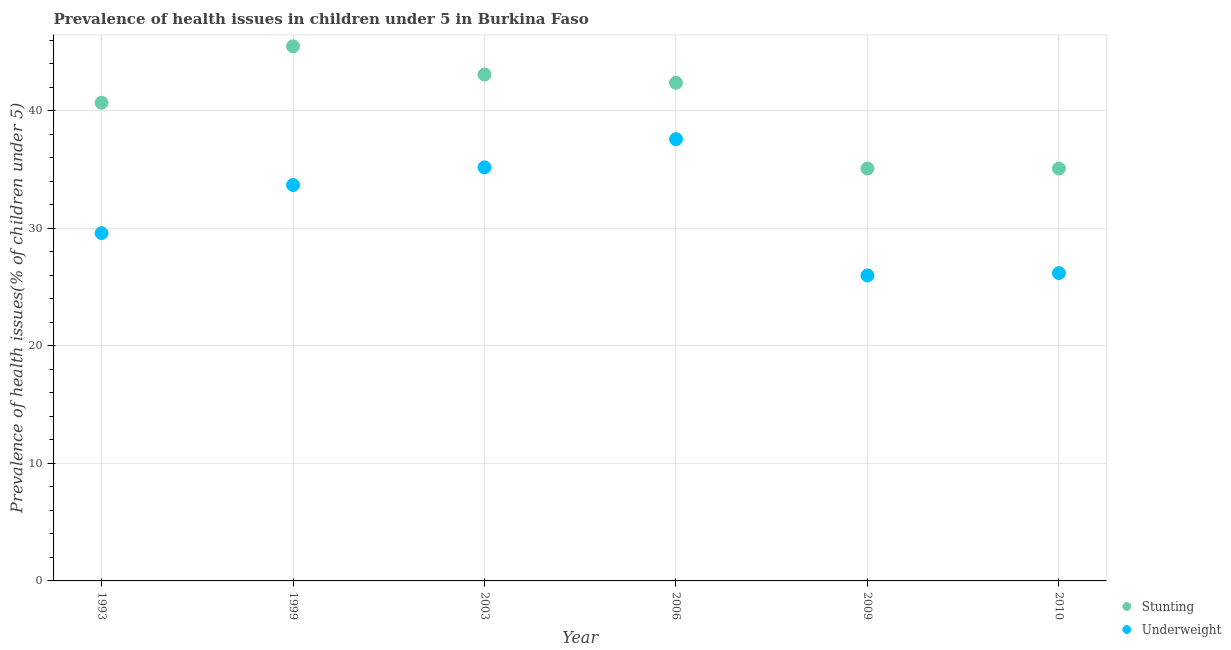What is the percentage of stunted children in 1999?
Your response must be concise. 45.5. Across all years, what is the maximum percentage of underweight children?
Your answer should be very brief. 37.6. Across all years, what is the minimum percentage of underweight children?
Give a very brief answer. 26. What is the total percentage of underweight children in the graph?
Provide a succinct answer. 188.3. What is the difference between the percentage of stunted children in 1993 and that in 2009?
Your answer should be compact. 5.6. What is the difference between the percentage of stunted children in 2003 and the percentage of underweight children in 2009?
Your answer should be very brief. 17.1. What is the average percentage of underweight children per year?
Offer a terse response. 31.38. In the year 2009, what is the difference between the percentage of underweight children and percentage of stunted children?
Ensure brevity in your answer.  -9.1. What is the ratio of the percentage of stunted children in 2003 to that in 2006?
Keep it short and to the point. 1.02. Is the difference between the percentage of underweight children in 1993 and 2010 greater than the difference between the percentage of stunted children in 1993 and 2010?
Ensure brevity in your answer.  No. What is the difference between the highest and the second highest percentage of underweight children?
Your answer should be very brief. 2.4. What is the difference between the highest and the lowest percentage of stunted children?
Offer a terse response. 10.4. In how many years, is the percentage of underweight children greater than the average percentage of underweight children taken over all years?
Keep it short and to the point. 3. Does the percentage of underweight children monotonically increase over the years?
Your answer should be very brief. No. Is the percentage of underweight children strictly greater than the percentage of stunted children over the years?
Provide a short and direct response. No. Is the percentage of underweight children strictly less than the percentage of stunted children over the years?
Provide a succinct answer. Yes. How many dotlines are there?
Provide a short and direct response. 2. How many years are there in the graph?
Provide a succinct answer. 6. Are the values on the major ticks of Y-axis written in scientific E-notation?
Make the answer very short. No. Does the graph contain any zero values?
Offer a terse response. No. Does the graph contain grids?
Offer a terse response. Yes. How many legend labels are there?
Provide a succinct answer. 2. How are the legend labels stacked?
Give a very brief answer. Vertical. What is the title of the graph?
Your response must be concise. Prevalence of health issues in children under 5 in Burkina Faso. What is the label or title of the Y-axis?
Ensure brevity in your answer.  Prevalence of health issues(% of children under 5). What is the Prevalence of health issues(% of children under 5) of Stunting in 1993?
Keep it short and to the point. 40.7. What is the Prevalence of health issues(% of children under 5) of Underweight in 1993?
Your response must be concise. 29.6. What is the Prevalence of health issues(% of children under 5) of Stunting in 1999?
Your answer should be compact. 45.5. What is the Prevalence of health issues(% of children under 5) in Underweight in 1999?
Provide a short and direct response. 33.7. What is the Prevalence of health issues(% of children under 5) of Stunting in 2003?
Keep it short and to the point. 43.1. What is the Prevalence of health issues(% of children under 5) of Underweight in 2003?
Your response must be concise. 35.2. What is the Prevalence of health issues(% of children under 5) in Stunting in 2006?
Your answer should be very brief. 42.4. What is the Prevalence of health issues(% of children under 5) in Underweight in 2006?
Your response must be concise. 37.6. What is the Prevalence of health issues(% of children under 5) in Stunting in 2009?
Your response must be concise. 35.1. What is the Prevalence of health issues(% of children under 5) of Stunting in 2010?
Your response must be concise. 35.1. What is the Prevalence of health issues(% of children under 5) in Underweight in 2010?
Make the answer very short. 26.2. Across all years, what is the maximum Prevalence of health issues(% of children under 5) in Stunting?
Your answer should be compact. 45.5. Across all years, what is the maximum Prevalence of health issues(% of children under 5) in Underweight?
Keep it short and to the point. 37.6. Across all years, what is the minimum Prevalence of health issues(% of children under 5) in Stunting?
Your answer should be very brief. 35.1. What is the total Prevalence of health issues(% of children under 5) in Stunting in the graph?
Your answer should be very brief. 241.9. What is the total Prevalence of health issues(% of children under 5) of Underweight in the graph?
Your response must be concise. 188.3. What is the difference between the Prevalence of health issues(% of children under 5) of Underweight in 1993 and that in 1999?
Make the answer very short. -4.1. What is the difference between the Prevalence of health issues(% of children under 5) in Underweight in 1993 and that in 2003?
Your response must be concise. -5.6. What is the difference between the Prevalence of health issues(% of children under 5) in Stunting in 1993 and that in 2006?
Offer a terse response. -1.7. What is the difference between the Prevalence of health issues(% of children under 5) of Stunting in 1993 and that in 2009?
Make the answer very short. 5.6. What is the difference between the Prevalence of health issues(% of children under 5) in Underweight in 1993 and that in 2009?
Keep it short and to the point. 3.6. What is the difference between the Prevalence of health issues(% of children under 5) in Underweight in 1993 and that in 2010?
Make the answer very short. 3.4. What is the difference between the Prevalence of health issues(% of children under 5) of Underweight in 1999 and that in 2003?
Your answer should be very brief. -1.5. What is the difference between the Prevalence of health issues(% of children under 5) in Underweight in 1999 and that in 2006?
Make the answer very short. -3.9. What is the difference between the Prevalence of health issues(% of children under 5) in Stunting in 1999 and that in 2009?
Your response must be concise. 10.4. What is the difference between the Prevalence of health issues(% of children under 5) in Stunting in 1999 and that in 2010?
Provide a succinct answer. 10.4. What is the difference between the Prevalence of health issues(% of children under 5) in Underweight in 2003 and that in 2006?
Your response must be concise. -2.4. What is the difference between the Prevalence of health issues(% of children under 5) in Stunting in 2003 and that in 2009?
Your answer should be compact. 8. What is the difference between the Prevalence of health issues(% of children under 5) in Underweight in 2003 and that in 2010?
Keep it short and to the point. 9. What is the difference between the Prevalence of health issues(% of children under 5) of Stunting in 2006 and that in 2009?
Provide a succinct answer. 7.3. What is the difference between the Prevalence of health issues(% of children under 5) of Stunting in 2006 and that in 2010?
Your answer should be very brief. 7.3. What is the difference between the Prevalence of health issues(% of children under 5) in Underweight in 2006 and that in 2010?
Make the answer very short. 11.4. What is the difference between the Prevalence of health issues(% of children under 5) in Stunting in 2009 and that in 2010?
Provide a succinct answer. 0. What is the difference between the Prevalence of health issues(% of children under 5) in Stunting in 1993 and the Prevalence of health issues(% of children under 5) in Underweight in 1999?
Provide a succinct answer. 7. What is the difference between the Prevalence of health issues(% of children under 5) in Stunting in 1993 and the Prevalence of health issues(% of children under 5) in Underweight in 2006?
Give a very brief answer. 3.1. What is the difference between the Prevalence of health issues(% of children under 5) in Stunting in 1993 and the Prevalence of health issues(% of children under 5) in Underweight in 2009?
Make the answer very short. 14.7. What is the difference between the Prevalence of health issues(% of children under 5) in Stunting in 1993 and the Prevalence of health issues(% of children under 5) in Underweight in 2010?
Provide a succinct answer. 14.5. What is the difference between the Prevalence of health issues(% of children under 5) in Stunting in 1999 and the Prevalence of health issues(% of children under 5) in Underweight in 2003?
Your response must be concise. 10.3. What is the difference between the Prevalence of health issues(% of children under 5) of Stunting in 1999 and the Prevalence of health issues(% of children under 5) of Underweight in 2010?
Provide a short and direct response. 19.3. What is the difference between the Prevalence of health issues(% of children under 5) in Stunting in 2003 and the Prevalence of health issues(% of children under 5) in Underweight in 2010?
Offer a terse response. 16.9. What is the difference between the Prevalence of health issues(% of children under 5) of Stunting in 2006 and the Prevalence of health issues(% of children under 5) of Underweight in 2009?
Give a very brief answer. 16.4. What is the difference between the Prevalence of health issues(% of children under 5) of Stunting in 2006 and the Prevalence of health issues(% of children under 5) of Underweight in 2010?
Provide a short and direct response. 16.2. What is the difference between the Prevalence of health issues(% of children under 5) of Stunting in 2009 and the Prevalence of health issues(% of children under 5) of Underweight in 2010?
Offer a terse response. 8.9. What is the average Prevalence of health issues(% of children under 5) of Stunting per year?
Give a very brief answer. 40.32. What is the average Prevalence of health issues(% of children under 5) in Underweight per year?
Keep it short and to the point. 31.38. In the year 1999, what is the difference between the Prevalence of health issues(% of children under 5) in Stunting and Prevalence of health issues(% of children under 5) in Underweight?
Your answer should be compact. 11.8. In the year 2009, what is the difference between the Prevalence of health issues(% of children under 5) in Stunting and Prevalence of health issues(% of children under 5) in Underweight?
Provide a short and direct response. 9.1. In the year 2010, what is the difference between the Prevalence of health issues(% of children under 5) of Stunting and Prevalence of health issues(% of children under 5) of Underweight?
Offer a terse response. 8.9. What is the ratio of the Prevalence of health issues(% of children under 5) in Stunting in 1993 to that in 1999?
Your answer should be compact. 0.89. What is the ratio of the Prevalence of health issues(% of children under 5) in Underweight in 1993 to that in 1999?
Provide a short and direct response. 0.88. What is the ratio of the Prevalence of health issues(% of children under 5) of Stunting in 1993 to that in 2003?
Your answer should be very brief. 0.94. What is the ratio of the Prevalence of health issues(% of children under 5) in Underweight in 1993 to that in 2003?
Give a very brief answer. 0.84. What is the ratio of the Prevalence of health issues(% of children under 5) in Stunting in 1993 to that in 2006?
Your response must be concise. 0.96. What is the ratio of the Prevalence of health issues(% of children under 5) in Underweight in 1993 to that in 2006?
Offer a very short reply. 0.79. What is the ratio of the Prevalence of health issues(% of children under 5) of Stunting in 1993 to that in 2009?
Provide a short and direct response. 1.16. What is the ratio of the Prevalence of health issues(% of children under 5) of Underweight in 1993 to that in 2009?
Make the answer very short. 1.14. What is the ratio of the Prevalence of health issues(% of children under 5) in Stunting in 1993 to that in 2010?
Keep it short and to the point. 1.16. What is the ratio of the Prevalence of health issues(% of children under 5) in Underweight in 1993 to that in 2010?
Provide a short and direct response. 1.13. What is the ratio of the Prevalence of health issues(% of children under 5) in Stunting in 1999 to that in 2003?
Offer a terse response. 1.06. What is the ratio of the Prevalence of health issues(% of children under 5) in Underweight in 1999 to that in 2003?
Ensure brevity in your answer.  0.96. What is the ratio of the Prevalence of health issues(% of children under 5) in Stunting in 1999 to that in 2006?
Keep it short and to the point. 1.07. What is the ratio of the Prevalence of health issues(% of children under 5) in Underweight in 1999 to that in 2006?
Your response must be concise. 0.9. What is the ratio of the Prevalence of health issues(% of children under 5) in Stunting in 1999 to that in 2009?
Keep it short and to the point. 1.3. What is the ratio of the Prevalence of health issues(% of children under 5) in Underweight in 1999 to that in 2009?
Your answer should be very brief. 1.3. What is the ratio of the Prevalence of health issues(% of children under 5) in Stunting in 1999 to that in 2010?
Make the answer very short. 1.3. What is the ratio of the Prevalence of health issues(% of children under 5) of Underweight in 1999 to that in 2010?
Your response must be concise. 1.29. What is the ratio of the Prevalence of health issues(% of children under 5) in Stunting in 2003 to that in 2006?
Keep it short and to the point. 1.02. What is the ratio of the Prevalence of health issues(% of children under 5) in Underweight in 2003 to that in 2006?
Your response must be concise. 0.94. What is the ratio of the Prevalence of health issues(% of children under 5) of Stunting in 2003 to that in 2009?
Your response must be concise. 1.23. What is the ratio of the Prevalence of health issues(% of children under 5) in Underweight in 2003 to that in 2009?
Offer a terse response. 1.35. What is the ratio of the Prevalence of health issues(% of children under 5) in Stunting in 2003 to that in 2010?
Make the answer very short. 1.23. What is the ratio of the Prevalence of health issues(% of children under 5) of Underweight in 2003 to that in 2010?
Give a very brief answer. 1.34. What is the ratio of the Prevalence of health issues(% of children under 5) in Stunting in 2006 to that in 2009?
Keep it short and to the point. 1.21. What is the ratio of the Prevalence of health issues(% of children under 5) of Underweight in 2006 to that in 2009?
Keep it short and to the point. 1.45. What is the ratio of the Prevalence of health issues(% of children under 5) in Stunting in 2006 to that in 2010?
Give a very brief answer. 1.21. What is the ratio of the Prevalence of health issues(% of children under 5) in Underweight in 2006 to that in 2010?
Your answer should be very brief. 1.44. What is the ratio of the Prevalence of health issues(% of children under 5) of Stunting in 2009 to that in 2010?
Ensure brevity in your answer.  1. What is the ratio of the Prevalence of health issues(% of children under 5) in Underweight in 2009 to that in 2010?
Ensure brevity in your answer.  0.99. What is the difference between the highest and the lowest Prevalence of health issues(% of children under 5) in Underweight?
Offer a very short reply. 11.6. 